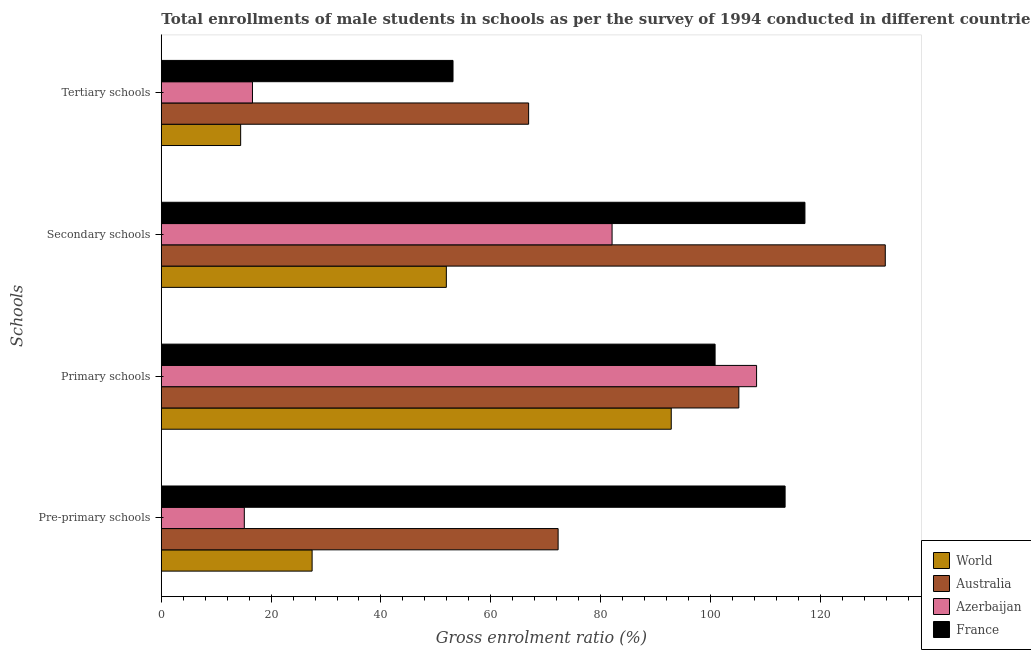Are the number of bars per tick equal to the number of legend labels?
Ensure brevity in your answer.  Yes. Are the number of bars on each tick of the Y-axis equal?
Provide a succinct answer. Yes. What is the label of the 1st group of bars from the top?
Give a very brief answer. Tertiary schools. What is the gross enrolment ratio(male) in tertiary schools in Azerbaijan?
Your response must be concise. 16.6. Across all countries, what is the maximum gross enrolment ratio(male) in pre-primary schools?
Provide a succinct answer. 113.61. Across all countries, what is the minimum gross enrolment ratio(male) in tertiary schools?
Ensure brevity in your answer.  14.45. In which country was the gross enrolment ratio(male) in primary schools maximum?
Your response must be concise. Azerbaijan. What is the total gross enrolment ratio(male) in primary schools in the graph?
Your answer should be very brief. 407.32. What is the difference between the gross enrolment ratio(male) in tertiary schools in France and that in World?
Provide a short and direct response. 38.68. What is the difference between the gross enrolment ratio(male) in secondary schools in Azerbaijan and the gross enrolment ratio(male) in primary schools in France?
Your answer should be compact. -18.76. What is the average gross enrolment ratio(male) in primary schools per country?
Offer a very short reply. 101.83. What is the difference between the gross enrolment ratio(male) in secondary schools and gross enrolment ratio(male) in primary schools in World?
Keep it short and to the point. -40.96. What is the ratio of the gross enrolment ratio(male) in pre-primary schools in Australia to that in France?
Keep it short and to the point. 0.64. Is the gross enrolment ratio(male) in primary schools in Australia less than that in France?
Ensure brevity in your answer.  No. Is the difference between the gross enrolment ratio(male) in primary schools in Australia and France greater than the difference between the gross enrolment ratio(male) in secondary schools in Australia and France?
Your answer should be compact. No. What is the difference between the highest and the second highest gross enrolment ratio(male) in secondary schools?
Ensure brevity in your answer.  14.63. What is the difference between the highest and the lowest gross enrolment ratio(male) in pre-primary schools?
Your response must be concise. 98.49. Is the sum of the gross enrolment ratio(male) in primary schools in Australia and Azerbaijan greater than the maximum gross enrolment ratio(male) in pre-primary schools across all countries?
Your response must be concise. Yes. Is it the case that in every country, the sum of the gross enrolment ratio(male) in tertiary schools and gross enrolment ratio(male) in secondary schools is greater than the sum of gross enrolment ratio(male) in primary schools and gross enrolment ratio(male) in pre-primary schools?
Your response must be concise. No. What does the 4th bar from the top in Pre-primary schools represents?
Your answer should be very brief. World. How many bars are there?
Provide a short and direct response. 16. Are all the bars in the graph horizontal?
Your answer should be compact. Yes. Are the values on the major ticks of X-axis written in scientific E-notation?
Your answer should be compact. No. How many legend labels are there?
Offer a very short reply. 4. How are the legend labels stacked?
Make the answer very short. Vertical. What is the title of the graph?
Your response must be concise. Total enrollments of male students in schools as per the survey of 1994 conducted in different countries. Does "Europe(all income levels)" appear as one of the legend labels in the graph?
Your answer should be very brief. No. What is the label or title of the X-axis?
Your answer should be compact. Gross enrolment ratio (%). What is the label or title of the Y-axis?
Your answer should be very brief. Schools. What is the Gross enrolment ratio (%) in World in Pre-primary schools?
Give a very brief answer. 27.46. What is the Gross enrolment ratio (%) in Australia in Pre-primary schools?
Your answer should be very brief. 72.27. What is the Gross enrolment ratio (%) in Azerbaijan in Pre-primary schools?
Keep it short and to the point. 15.12. What is the Gross enrolment ratio (%) of France in Pre-primary schools?
Your answer should be very brief. 113.61. What is the Gross enrolment ratio (%) in World in Primary schools?
Provide a succinct answer. 92.87. What is the Gross enrolment ratio (%) in Australia in Primary schools?
Make the answer very short. 105.18. What is the Gross enrolment ratio (%) in Azerbaijan in Primary schools?
Offer a terse response. 108.41. What is the Gross enrolment ratio (%) in France in Primary schools?
Offer a very short reply. 100.86. What is the Gross enrolment ratio (%) of World in Secondary schools?
Offer a terse response. 51.91. What is the Gross enrolment ratio (%) in Australia in Secondary schools?
Your answer should be compact. 131.85. What is the Gross enrolment ratio (%) of Azerbaijan in Secondary schools?
Offer a very short reply. 82.1. What is the Gross enrolment ratio (%) of France in Secondary schools?
Offer a terse response. 117.22. What is the Gross enrolment ratio (%) of World in Tertiary schools?
Your answer should be very brief. 14.45. What is the Gross enrolment ratio (%) in Australia in Tertiary schools?
Ensure brevity in your answer.  66.89. What is the Gross enrolment ratio (%) in Azerbaijan in Tertiary schools?
Ensure brevity in your answer.  16.6. What is the Gross enrolment ratio (%) in France in Tertiary schools?
Offer a terse response. 53.12. Across all Schools, what is the maximum Gross enrolment ratio (%) in World?
Keep it short and to the point. 92.87. Across all Schools, what is the maximum Gross enrolment ratio (%) in Australia?
Your answer should be compact. 131.85. Across all Schools, what is the maximum Gross enrolment ratio (%) of Azerbaijan?
Ensure brevity in your answer.  108.41. Across all Schools, what is the maximum Gross enrolment ratio (%) of France?
Ensure brevity in your answer.  117.22. Across all Schools, what is the minimum Gross enrolment ratio (%) in World?
Keep it short and to the point. 14.45. Across all Schools, what is the minimum Gross enrolment ratio (%) in Australia?
Your response must be concise. 66.89. Across all Schools, what is the minimum Gross enrolment ratio (%) of Azerbaijan?
Your answer should be very brief. 15.12. Across all Schools, what is the minimum Gross enrolment ratio (%) of France?
Provide a short and direct response. 53.12. What is the total Gross enrolment ratio (%) of World in the graph?
Your response must be concise. 186.69. What is the total Gross enrolment ratio (%) in Australia in the graph?
Your answer should be very brief. 376.19. What is the total Gross enrolment ratio (%) of Azerbaijan in the graph?
Offer a terse response. 222.22. What is the total Gross enrolment ratio (%) in France in the graph?
Keep it short and to the point. 384.81. What is the difference between the Gross enrolment ratio (%) in World in Pre-primary schools and that in Primary schools?
Provide a short and direct response. -65.41. What is the difference between the Gross enrolment ratio (%) of Australia in Pre-primary schools and that in Primary schools?
Offer a very short reply. -32.91. What is the difference between the Gross enrolment ratio (%) of Azerbaijan in Pre-primary schools and that in Primary schools?
Your answer should be very brief. -93.3. What is the difference between the Gross enrolment ratio (%) in France in Pre-primary schools and that in Primary schools?
Offer a very short reply. 12.75. What is the difference between the Gross enrolment ratio (%) in World in Pre-primary schools and that in Secondary schools?
Offer a very short reply. -24.45. What is the difference between the Gross enrolment ratio (%) in Australia in Pre-primary schools and that in Secondary schools?
Your answer should be very brief. -59.58. What is the difference between the Gross enrolment ratio (%) of Azerbaijan in Pre-primary schools and that in Secondary schools?
Give a very brief answer. -66.98. What is the difference between the Gross enrolment ratio (%) in France in Pre-primary schools and that in Secondary schools?
Offer a terse response. -3.61. What is the difference between the Gross enrolment ratio (%) in World in Pre-primary schools and that in Tertiary schools?
Your answer should be very brief. 13.02. What is the difference between the Gross enrolment ratio (%) of Australia in Pre-primary schools and that in Tertiary schools?
Offer a terse response. 5.37. What is the difference between the Gross enrolment ratio (%) in Azerbaijan in Pre-primary schools and that in Tertiary schools?
Your response must be concise. -1.49. What is the difference between the Gross enrolment ratio (%) in France in Pre-primary schools and that in Tertiary schools?
Ensure brevity in your answer.  60.48. What is the difference between the Gross enrolment ratio (%) of World in Primary schools and that in Secondary schools?
Your answer should be very brief. 40.96. What is the difference between the Gross enrolment ratio (%) of Australia in Primary schools and that in Secondary schools?
Offer a very short reply. -26.67. What is the difference between the Gross enrolment ratio (%) of Azerbaijan in Primary schools and that in Secondary schools?
Offer a very short reply. 26.32. What is the difference between the Gross enrolment ratio (%) of France in Primary schools and that in Secondary schools?
Your answer should be very brief. -16.36. What is the difference between the Gross enrolment ratio (%) in World in Primary schools and that in Tertiary schools?
Offer a very short reply. 78.42. What is the difference between the Gross enrolment ratio (%) of Australia in Primary schools and that in Tertiary schools?
Provide a succinct answer. 38.29. What is the difference between the Gross enrolment ratio (%) of Azerbaijan in Primary schools and that in Tertiary schools?
Make the answer very short. 91.81. What is the difference between the Gross enrolment ratio (%) of France in Primary schools and that in Tertiary schools?
Ensure brevity in your answer.  47.73. What is the difference between the Gross enrolment ratio (%) in World in Secondary schools and that in Tertiary schools?
Your answer should be very brief. 37.46. What is the difference between the Gross enrolment ratio (%) in Australia in Secondary schools and that in Tertiary schools?
Keep it short and to the point. 64.96. What is the difference between the Gross enrolment ratio (%) in Azerbaijan in Secondary schools and that in Tertiary schools?
Your answer should be compact. 65.49. What is the difference between the Gross enrolment ratio (%) in France in Secondary schools and that in Tertiary schools?
Your answer should be compact. 64.09. What is the difference between the Gross enrolment ratio (%) of World in Pre-primary schools and the Gross enrolment ratio (%) of Australia in Primary schools?
Make the answer very short. -77.72. What is the difference between the Gross enrolment ratio (%) of World in Pre-primary schools and the Gross enrolment ratio (%) of Azerbaijan in Primary schools?
Offer a terse response. -80.95. What is the difference between the Gross enrolment ratio (%) of World in Pre-primary schools and the Gross enrolment ratio (%) of France in Primary schools?
Offer a very short reply. -73.39. What is the difference between the Gross enrolment ratio (%) in Australia in Pre-primary schools and the Gross enrolment ratio (%) in Azerbaijan in Primary schools?
Provide a succinct answer. -36.14. What is the difference between the Gross enrolment ratio (%) in Australia in Pre-primary schools and the Gross enrolment ratio (%) in France in Primary schools?
Provide a succinct answer. -28.59. What is the difference between the Gross enrolment ratio (%) of Azerbaijan in Pre-primary schools and the Gross enrolment ratio (%) of France in Primary schools?
Ensure brevity in your answer.  -85.74. What is the difference between the Gross enrolment ratio (%) of World in Pre-primary schools and the Gross enrolment ratio (%) of Australia in Secondary schools?
Provide a short and direct response. -104.39. What is the difference between the Gross enrolment ratio (%) in World in Pre-primary schools and the Gross enrolment ratio (%) in Azerbaijan in Secondary schools?
Make the answer very short. -54.63. What is the difference between the Gross enrolment ratio (%) of World in Pre-primary schools and the Gross enrolment ratio (%) of France in Secondary schools?
Your response must be concise. -89.76. What is the difference between the Gross enrolment ratio (%) of Australia in Pre-primary schools and the Gross enrolment ratio (%) of Azerbaijan in Secondary schools?
Your response must be concise. -9.83. What is the difference between the Gross enrolment ratio (%) of Australia in Pre-primary schools and the Gross enrolment ratio (%) of France in Secondary schools?
Keep it short and to the point. -44.95. What is the difference between the Gross enrolment ratio (%) of Azerbaijan in Pre-primary schools and the Gross enrolment ratio (%) of France in Secondary schools?
Give a very brief answer. -102.1. What is the difference between the Gross enrolment ratio (%) of World in Pre-primary schools and the Gross enrolment ratio (%) of Australia in Tertiary schools?
Offer a terse response. -39.43. What is the difference between the Gross enrolment ratio (%) of World in Pre-primary schools and the Gross enrolment ratio (%) of Azerbaijan in Tertiary schools?
Give a very brief answer. 10.86. What is the difference between the Gross enrolment ratio (%) of World in Pre-primary schools and the Gross enrolment ratio (%) of France in Tertiary schools?
Ensure brevity in your answer.  -25.66. What is the difference between the Gross enrolment ratio (%) in Australia in Pre-primary schools and the Gross enrolment ratio (%) in Azerbaijan in Tertiary schools?
Provide a short and direct response. 55.67. What is the difference between the Gross enrolment ratio (%) of Australia in Pre-primary schools and the Gross enrolment ratio (%) of France in Tertiary schools?
Your answer should be compact. 19.14. What is the difference between the Gross enrolment ratio (%) of Azerbaijan in Pre-primary schools and the Gross enrolment ratio (%) of France in Tertiary schools?
Keep it short and to the point. -38.01. What is the difference between the Gross enrolment ratio (%) of World in Primary schools and the Gross enrolment ratio (%) of Australia in Secondary schools?
Provide a short and direct response. -38.98. What is the difference between the Gross enrolment ratio (%) in World in Primary schools and the Gross enrolment ratio (%) in Azerbaijan in Secondary schools?
Your answer should be compact. 10.77. What is the difference between the Gross enrolment ratio (%) of World in Primary schools and the Gross enrolment ratio (%) of France in Secondary schools?
Keep it short and to the point. -24.35. What is the difference between the Gross enrolment ratio (%) in Australia in Primary schools and the Gross enrolment ratio (%) in Azerbaijan in Secondary schools?
Keep it short and to the point. 23.09. What is the difference between the Gross enrolment ratio (%) of Australia in Primary schools and the Gross enrolment ratio (%) of France in Secondary schools?
Ensure brevity in your answer.  -12.04. What is the difference between the Gross enrolment ratio (%) in Azerbaijan in Primary schools and the Gross enrolment ratio (%) in France in Secondary schools?
Provide a short and direct response. -8.81. What is the difference between the Gross enrolment ratio (%) of World in Primary schools and the Gross enrolment ratio (%) of Australia in Tertiary schools?
Offer a very short reply. 25.98. What is the difference between the Gross enrolment ratio (%) of World in Primary schools and the Gross enrolment ratio (%) of Azerbaijan in Tertiary schools?
Your answer should be very brief. 76.27. What is the difference between the Gross enrolment ratio (%) of World in Primary schools and the Gross enrolment ratio (%) of France in Tertiary schools?
Make the answer very short. 39.74. What is the difference between the Gross enrolment ratio (%) in Australia in Primary schools and the Gross enrolment ratio (%) in Azerbaijan in Tertiary schools?
Ensure brevity in your answer.  88.58. What is the difference between the Gross enrolment ratio (%) of Australia in Primary schools and the Gross enrolment ratio (%) of France in Tertiary schools?
Provide a succinct answer. 52.06. What is the difference between the Gross enrolment ratio (%) of Azerbaijan in Primary schools and the Gross enrolment ratio (%) of France in Tertiary schools?
Your response must be concise. 55.29. What is the difference between the Gross enrolment ratio (%) of World in Secondary schools and the Gross enrolment ratio (%) of Australia in Tertiary schools?
Keep it short and to the point. -14.98. What is the difference between the Gross enrolment ratio (%) in World in Secondary schools and the Gross enrolment ratio (%) in Azerbaijan in Tertiary schools?
Keep it short and to the point. 35.31. What is the difference between the Gross enrolment ratio (%) in World in Secondary schools and the Gross enrolment ratio (%) in France in Tertiary schools?
Provide a short and direct response. -1.21. What is the difference between the Gross enrolment ratio (%) in Australia in Secondary schools and the Gross enrolment ratio (%) in Azerbaijan in Tertiary schools?
Make the answer very short. 115.25. What is the difference between the Gross enrolment ratio (%) in Australia in Secondary schools and the Gross enrolment ratio (%) in France in Tertiary schools?
Your answer should be very brief. 78.73. What is the difference between the Gross enrolment ratio (%) of Azerbaijan in Secondary schools and the Gross enrolment ratio (%) of France in Tertiary schools?
Your response must be concise. 28.97. What is the average Gross enrolment ratio (%) in World per Schools?
Offer a terse response. 46.67. What is the average Gross enrolment ratio (%) of Australia per Schools?
Give a very brief answer. 94.05. What is the average Gross enrolment ratio (%) of Azerbaijan per Schools?
Keep it short and to the point. 55.56. What is the average Gross enrolment ratio (%) of France per Schools?
Provide a short and direct response. 96.2. What is the difference between the Gross enrolment ratio (%) of World and Gross enrolment ratio (%) of Australia in Pre-primary schools?
Offer a terse response. -44.8. What is the difference between the Gross enrolment ratio (%) in World and Gross enrolment ratio (%) in Azerbaijan in Pre-primary schools?
Your response must be concise. 12.35. What is the difference between the Gross enrolment ratio (%) in World and Gross enrolment ratio (%) in France in Pre-primary schools?
Offer a very short reply. -86.14. What is the difference between the Gross enrolment ratio (%) in Australia and Gross enrolment ratio (%) in Azerbaijan in Pre-primary schools?
Your answer should be compact. 57.15. What is the difference between the Gross enrolment ratio (%) of Australia and Gross enrolment ratio (%) of France in Pre-primary schools?
Your answer should be compact. -41.34. What is the difference between the Gross enrolment ratio (%) in Azerbaijan and Gross enrolment ratio (%) in France in Pre-primary schools?
Keep it short and to the point. -98.49. What is the difference between the Gross enrolment ratio (%) of World and Gross enrolment ratio (%) of Australia in Primary schools?
Offer a very short reply. -12.31. What is the difference between the Gross enrolment ratio (%) of World and Gross enrolment ratio (%) of Azerbaijan in Primary schools?
Give a very brief answer. -15.54. What is the difference between the Gross enrolment ratio (%) of World and Gross enrolment ratio (%) of France in Primary schools?
Offer a very short reply. -7.99. What is the difference between the Gross enrolment ratio (%) of Australia and Gross enrolment ratio (%) of Azerbaijan in Primary schools?
Your response must be concise. -3.23. What is the difference between the Gross enrolment ratio (%) in Australia and Gross enrolment ratio (%) in France in Primary schools?
Provide a succinct answer. 4.33. What is the difference between the Gross enrolment ratio (%) in Azerbaijan and Gross enrolment ratio (%) in France in Primary schools?
Your answer should be very brief. 7.56. What is the difference between the Gross enrolment ratio (%) of World and Gross enrolment ratio (%) of Australia in Secondary schools?
Ensure brevity in your answer.  -79.94. What is the difference between the Gross enrolment ratio (%) in World and Gross enrolment ratio (%) in Azerbaijan in Secondary schools?
Provide a succinct answer. -30.18. What is the difference between the Gross enrolment ratio (%) in World and Gross enrolment ratio (%) in France in Secondary schools?
Your answer should be compact. -65.31. What is the difference between the Gross enrolment ratio (%) in Australia and Gross enrolment ratio (%) in Azerbaijan in Secondary schools?
Keep it short and to the point. 49.76. What is the difference between the Gross enrolment ratio (%) of Australia and Gross enrolment ratio (%) of France in Secondary schools?
Keep it short and to the point. 14.63. What is the difference between the Gross enrolment ratio (%) of Azerbaijan and Gross enrolment ratio (%) of France in Secondary schools?
Keep it short and to the point. -35.12. What is the difference between the Gross enrolment ratio (%) of World and Gross enrolment ratio (%) of Australia in Tertiary schools?
Provide a succinct answer. -52.45. What is the difference between the Gross enrolment ratio (%) of World and Gross enrolment ratio (%) of Azerbaijan in Tertiary schools?
Your answer should be very brief. -2.15. What is the difference between the Gross enrolment ratio (%) of World and Gross enrolment ratio (%) of France in Tertiary schools?
Offer a very short reply. -38.68. What is the difference between the Gross enrolment ratio (%) of Australia and Gross enrolment ratio (%) of Azerbaijan in Tertiary schools?
Offer a terse response. 50.29. What is the difference between the Gross enrolment ratio (%) of Australia and Gross enrolment ratio (%) of France in Tertiary schools?
Your response must be concise. 13.77. What is the difference between the Gross enrolment ratio (%) of Azerbaijan and Gross enrolment ratio (%) of France in Tertiary schools?
Your response must be concise. -36.52. What is the ratio of the Gross enrolment ratio (%) of World in Pre-primary schools to that in Primary schools?
Make the answer very short. 0.3. What is the ratio of the Gross enrolment ratio (%) in Australia in Pre-primary schools to that in Primary schools?
Give a very brief answer. 0.69. What is the ratio of the Gross enrolment ratio (%) of Azerbaijan in Pre-primary schools to that in Primary schools?
Your answer should be very brief. 0.14. What is the ratio of the Gross enrolment ratio (%) of France in Pre-primary schools to that in Primary schools?
Provide a succinct answer. 1.13. What is the ratio of the Gross enrolment ratio (%) of World in Pre-primary schools to that in Secondary schools?
Give a very brief answer. 0.53. What is the ratio of the Gross enrolment ratio (%) of Australia in Pre-primary schools to that in Secondary schools?
Provide a short and direct response. 0.55. What is the ratio of the Gross enrolment ratio (%) in Azerbaijan in Pre-primary schools to that in Secondary schools?
Provide a succinct answer. 0.18. What is the ratio of the Gross enrolment ratio (%) of France in Pre-primary schools to that in Secondary schools?
Provide a succinct answer. 0.97. What is the ratio of the Gross enrolment ratio (%) of World in Pre-primary schools to that in Tertiary schools?
Your answer should be compact. 1.9. What is the ratio of the Gross enrolment ratio (%) in Australia in Pre-primary schools to that in Tertiary schools?
Ensure brevity in your answer.  1.08. What is the ratio of the Gross enrolment ratio (%) in Azerbaijan in Pre-primary schools to that in Tertiary schools?
Offer a terse response. 0.91. What is the ratio of the Gross enrolment ratio (%) in France in Pre-primary schools to that in Tertiary schools?
Provide a succinct answer. 2.14. What is the ratio of the Gross enrolment ratio (%) of World in Primary schools to that in Secondary schools?
Make the answer very short. 1.79. What is the ratio of the Gross enrolment ratio (%) of Australia in Primary schools to that in Secondary schools?
Give a very brief answer. 0.8. What is the ratio of the Gross enrolment ratio (%) of Azerbaijan in Primary schools to that in Secondary schools?
Your answer should be very brief. 1.32. What is the ratio of the Gross enrolment ratio (%) in France in Primary schools to that in Secondary schools?
Offer a very short reply. 0.86. What is the ratio of the Gross enrolment ratio (%) in World in Primary schools to that in Tertiary schools?
Offer a very short reply. 6.43. What is the ratio of the Gross enrolment ratio (%) in Australia in Primary schools to that in Tertiary schools?
Your answer should be very brief. 1.57. What is the ratio of the Gross enrolment ratio (%) in Azerbaijan in Primary schools to that in Tertiary schools?
Your answer should be compact. 6.53. What is the ratio of the Gross enrolment ratio (%) of France in Primary schools to that in Tertiary schools?
Your response must be concise. 1.9. What is the ratio of the Gross enrolment ratio (%) in World in Secondary schools to that in Tertiary schools?
Your answer should be compact. 3.59. What is the ratio of the Gross enrolment ratio (%) of Australia in Secondary schools to that in Tertiary schools?
Provide a succinct answer. 1.97. What is the ratio of the Gross enrolment ratio (%) of Azerbaijan in Secondary schools to that in Tertiary schools?
Keep it short and to the point. 4.94. What is the ratio of the Gross enrolment ratio (%) in France in Secondary schools to that in Tertiary schools?
Keep it short and to the point. 2.21. What is the difference between the highest and the second highest Gross enrolment ratio (%) in World?
Offer a very short reply. 40.96. What is the difference between the highest and the second highest Gross enrolment ratio (%) of Australia?
Provide a succinct answer. 26.67. What is the difference between the highest and the second highest Gross enrolment ratio (%) of Azerbaijan?
Your response must be concise. 26.32. What is the difference between the highest and the second highest Gross enrolment ratio (%) in France?
Provide a short and direct response. 3.61. What is the difference between the highest and the lowest Gross enrolment ratio (%) in World?
Your response must be concise. 78.42. What is the difference between the highest and the lowest Gross enrolment ratio (%) in Australia?
Offer a terse response. 64.96. What is the difference between the highest and the lowest Gross enrolment ratio (%) in Azerbaijan?
Keep it short and to the point. 93.3. What is the difference between the highest and the lowest Gross enrolment ratio (%) of France?
Give a very brief answer. 64.09. 